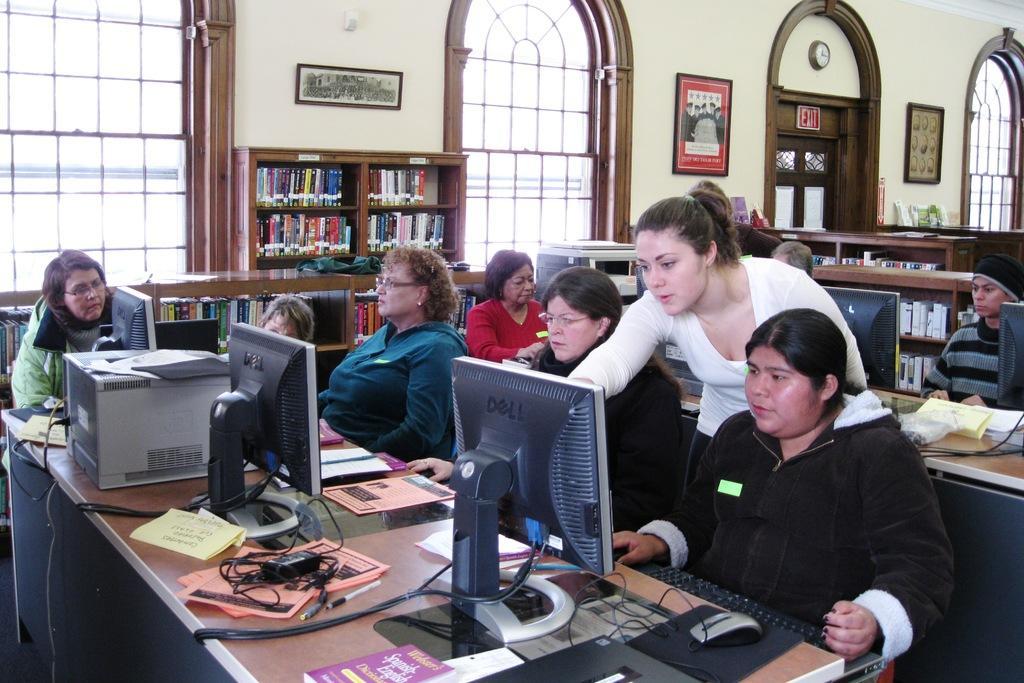Please provide a concise description of this image. In this image there are a few people sitting in front of the table, one of them is standing. On the table there are monitors, keyboards, mouse, mouse pads, cables, papers, books, CPU and other objects, behind them there are tracks stored with books. In the background there is a wall with windows and frames are hanging. 